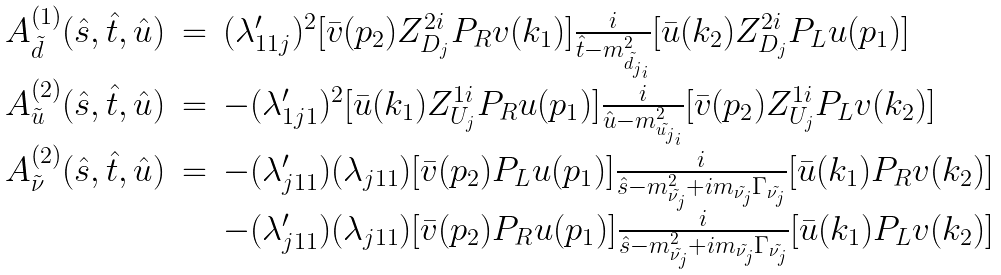<formula> <loc_0><loc_0><loc_500><loc_500>\begin{array} { l l l } A ^ { ( 1 ) } _ { \tilde { d } } ( \hat { s } , \hat { t } , \hat { u } ) & = & ( \lambda ^ { \prime } _ { 1 1 j } ) ^ { 2 } [ \bar { v } ( p _ { 2 } ) Z _ { D _ { j } } ^ { 2 i } P _ { R } v ( k _ { 1 } ) ] \frac { i } { \hat { t } - m _ { \tilde { d _ { j } } _ { i } } ^ { 2 } } [ \bar { u } ( k _ { 2 } ) Z _ { D _ { j } } ^ { 2 i } P _ { L } u ( p _ { 1 } ) ] \\ A ^ { ( 2 ) } _ { \tilde { u } } ( \hat { s } , \hat { t } , \hat { u } ) & = & - ( \lambda ^ { \prime } _ { 1 j 1 } ) ^ { 2 } [ \bar { u } ( k _ { 1 } ) Z _ { U _ { j } } ^ { 1 i } P _ { R } u ( p _ { 1 } ) ] \frac { i } { \hat { u } - m _ { \tilde { u _ { j } } _ { i } } ^ { 2 } } [ \bar { v } ( p _ { 2 } ) Z _ { U _ { j } } ^ { 1 i } P _ { L } v ( k _ { 2 } ) ] \\ A ^ { ( 2 ) } _ { \tilde { \nu } } ( \hat { s } , \hat { t } , \hat { u } ) & = & - ( \lambda ^ { \prime } _ { j 1 1 } ) ( \lambda _ { j 1 1 } ) [ \bar { v } ( p _ { 2 } ) P _ { L } u ( p _ { 1 } ) ] \frac { i } { \hat { s } - m _ { \tilde { \nu _ { j } } } ^ { 2 } + i m _ { \tilde { \nu _ { j } } } \Gamma _ { \tilde { \nu _ { j } } } } [ \bar { u } ( k _ { 1 } ) P _ { R } v ( k _ { 2 } ) ] \\ & & - ( \lambda ^ { \prime } _ { j 1 1 } ) ( \lambda _ { j 1 1 } ) [ \bar { v } ( p _ { 2 } ) P _ { R } u ( p _ { 1 } ) ] \frac { i } { \hat { s } - m _ { \tilde { \nu _ { j } } } ^ { 2 } + i m _ { \tilde { \nu _ { j } } } \Gamma _ { \tilde { \nu _ { j } } } } [ \bar { u } ( k _ { 1 } ) P _ { L } v ( k _ { 2 } ) ] \\ \end{array}</formula> 